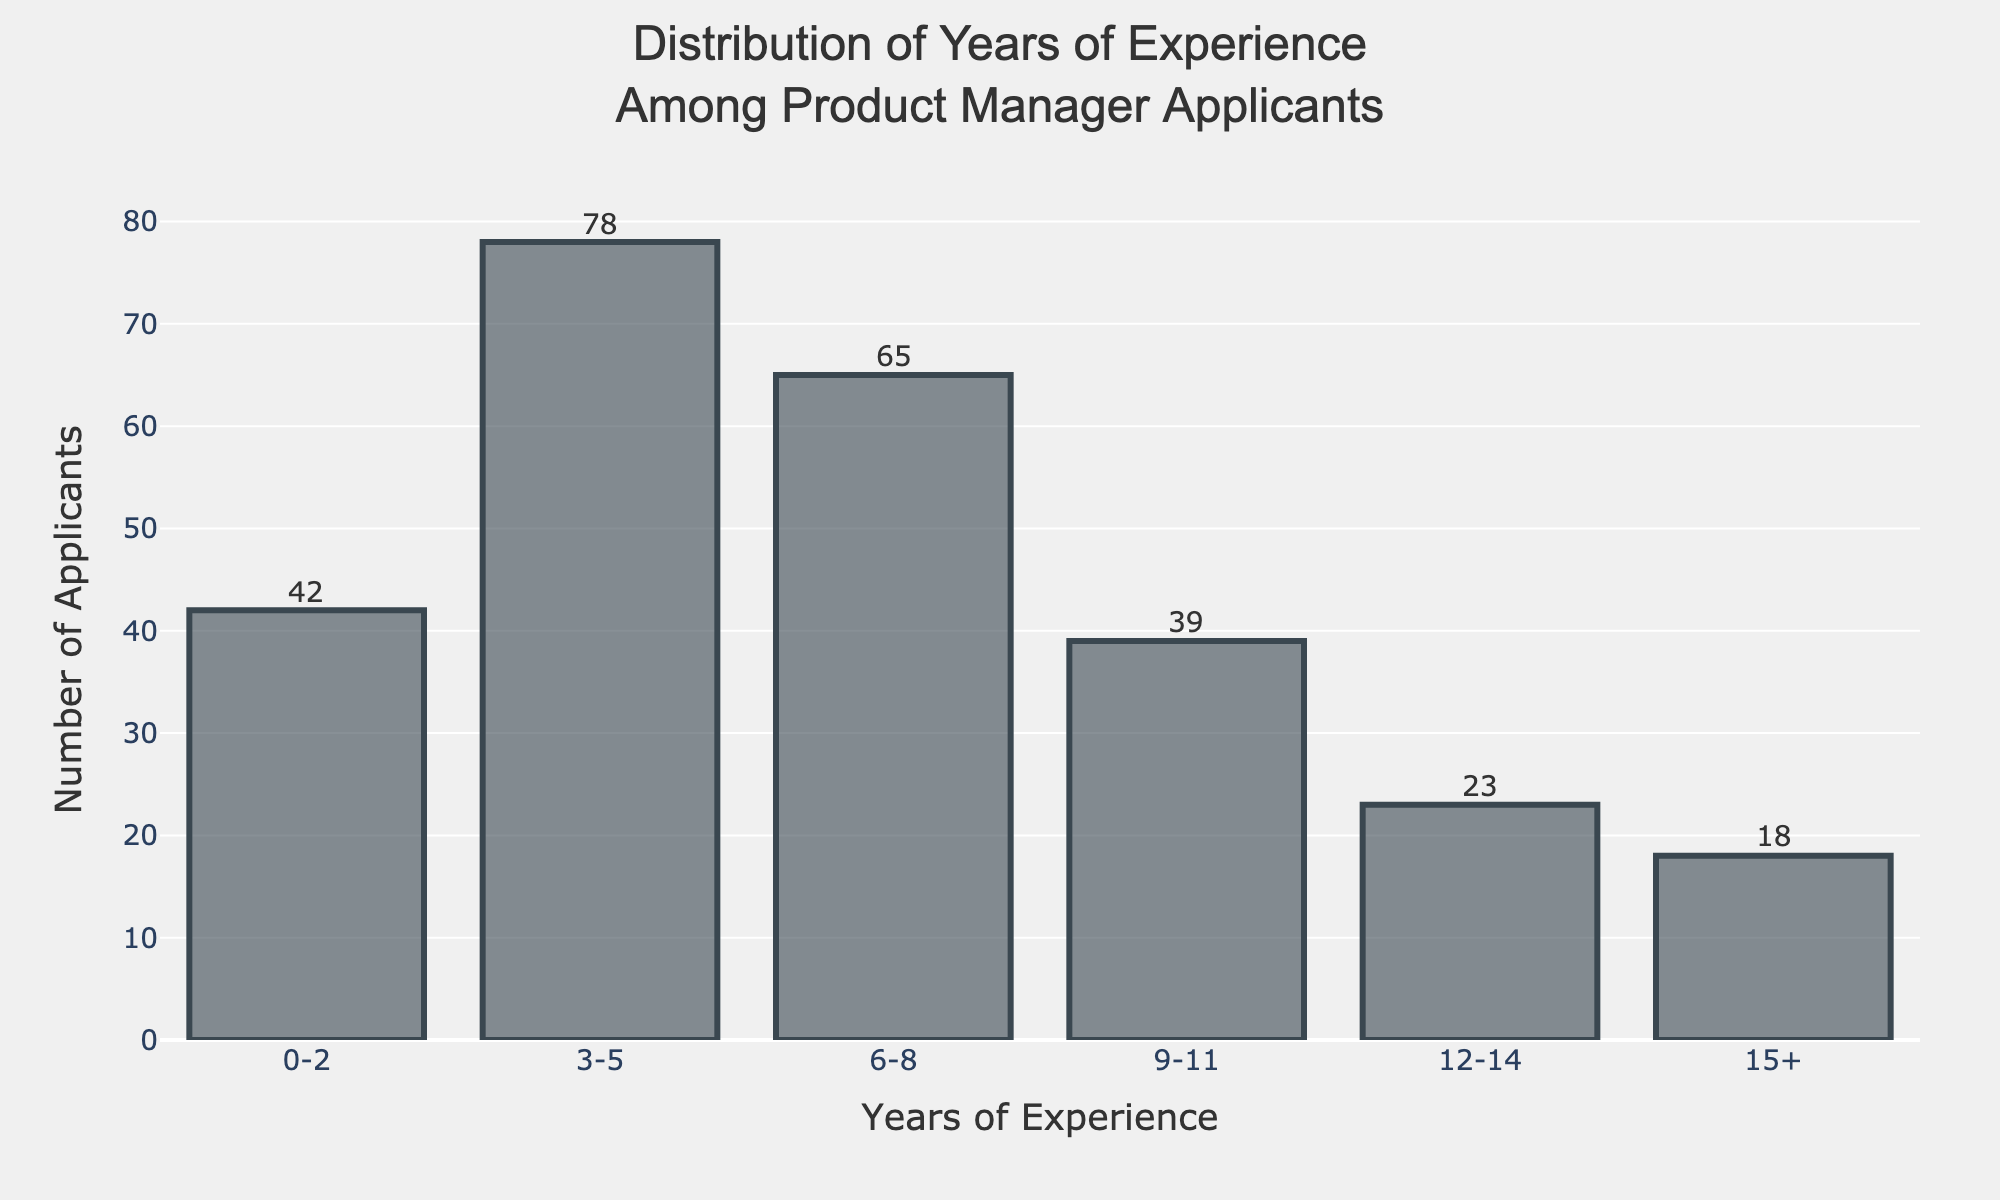What's the title of the figure? The title of the figure is centrally displayed at the top and reads "Distribution of Years of Experience Among Product Manager Applicants".
Answer: Distribution of Years of Experience Among Product Manager Applicants What are the labels on the X and Y axes? The X-axis is labeled "Years of Experience" and the Y-axis is labeled "Number of Applicants". These labels are displayed at the base and the left side of the figure, respectively.
Answer: Years of Experience, Number of Applicants Which group of applicants has the highest number? By looking at the height of the bars, we can see that the group with "3-5 years of experience" has the highest number of applicants, which is 78.
Answer: 3-5 years of experience How many applicants have 12-14 years of experience? In the figure, the bar corresponding to "12-14 years of experience" reaches to the value of 23 on the Y-axis, indicating there are 23 applicants in this category.
Answer: 23 What is the total number of applicants with 9 or more years of experience? Adding the number of applicants from the 9-11, 12-14, and 15+ groups: 39 (9-11 years) + 23 (12-14 years) + 18 (15+ years) = 80.
Answer: 80 Which group of applicants is the smallest, and how many applicants are in it? The bar for the group "15+" is the shortest, indicating it has the fewest applicants with a total of 18.
Answer: 15+, 18 Between which two consecutive experience groups is the largest difference in the number of applicants? Calculating the differences between consecutive groups: 
- (3-5 and 0-2): 78 - 42 = 36 
- (6-8 and 3-5): 78 - 65 = 13 
- (9-11 and 6-8): 65 - 39 = 26
- (12-14 and 9-11): 39 - 23 = 16
- (15+ and 12-14): 23 - 18 = 5
The largest difference is between the "3-5" and "0-2" years of experience groups with a difference of 36 applicants.
Answer: 3-5 and 0-2, 36 What percentage of the total number of applicants has 0-2 years of experience? First, calculate the total number of applicants: 42 + 78 + 65 + 39 + 23 + 18 = 265. Then, find the percentage: (42 / 265) * 100 ≈ 15.85%.
Answer: 15.85% How many more applicants have 6-8 years of experience compared to 0-2 years of experience? The number of applicants with 6-8 years is 65, and the number of applicants with 0-2 years is 42. The difference is 65 - 42 = 23 applicants.
Answer: 23 